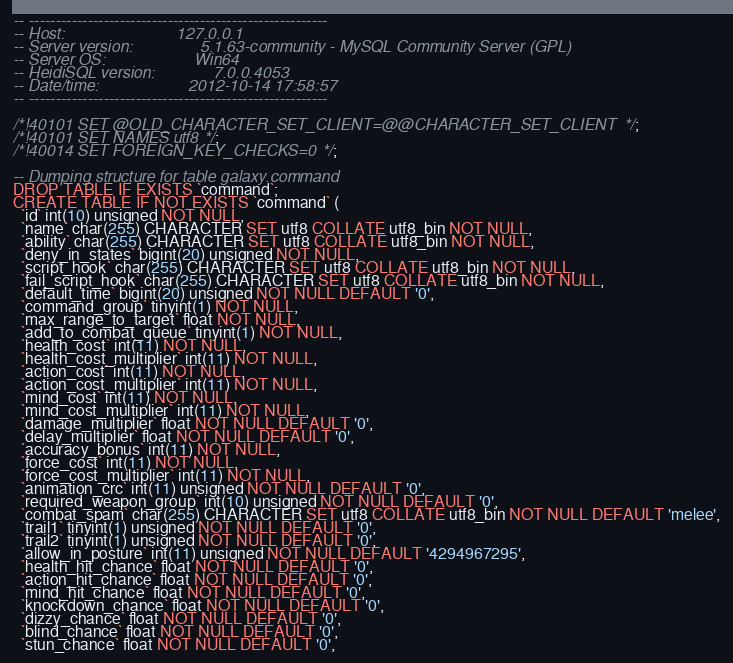<code> <loc_0><loc_0><loc_500><loc_500><_SQL_>-- --------------------------------------------------------
-- Host:                         127.0.0.1
-- Server version:               5.1.63-community - MySQL Community Server (GPL)
-- Server OS:                    Win64
-- HeidiSQL version:             7.0.0.4053
-- Date/time:                    2012-10-14 17:58:57
-- --------------------------------------------------------

/*!40101 SET @OLD_CHARACTER_SET_CLIENT=@@CHARACTER_SET_CLIENT */;
/*!40101 SET NAMES utf8 */;
/*!40014 SET FOREIGN_KEY_CHECKS=0 */;

-- Dumping structure for table galaxy.command
DROP TABLE IF EXISTS `command`;
CREATE TABLE IF NOT EXISTS `command` (
  `id` int(10) unsigned NOT NULL,
  `name` char(255) CHARACTER SET utf8 COLLATE utf8_bin NOT NULL,
  `ability` char(255) CHARACTER SET utf8 COLLATE utf8_bin NOT NULL,
  `deny_in_states` bigint(20) unsigned NOT NULL,
  `script_hook` char(255) CHARACTER SET utf8 COLLATE utf8_bin NOT NULL,
  `fail_script_hook` char(255) CHARACTER SET utf8 COLLATE utf8_bin NOT NULL,
  `default_time` bigint(20) unsigned NOT NULL DEFAULT '0',
  `command_group` tinyint(1) NOT NULL,
  `max_range_to_target` float NOT NULL,
  `add_to_combat_queue` tinyint(1) NOT NULL,
  `health_cost` int(11) NOT NULL,
  `health_cost_multiplier` int(11) NOT NULL,
  `action_cost` int(11) NOT NULL,
  `action_cost_multiplier` int(11) NOT NULL,
  `mind_cost` int(11) NOT NULL,
  `mind_cost_multiplier` int(11) NOT NULL,
  `damage_multiplier` float NOT NULL DEFAULT '0',
  `delay_multiplier` float NOT NULL DEFAULT '0',
  `accuracy_bonus` int(11) NOT NULL,
  `force_cost` int(11) NOT NULL,
  `force_cost_multiplier` int(11) NOT NULL,
  `animation_crc` int(11) unsigned NOT NULL DEFAULT '0',
  `required_weapon_group` int(10) unsigned NOT NULL DEFAULT '0',
  `combat_spam` char(255) CHARACTER SET utf8 COLLATE utf8_bin NOT NULL DEFAULT 'melee',
  `trail1` tinyint(1) unsigned NOT NULL DEFAULT '0',
  `trail2` tinyint(1) unsigned NOT NULL DEFAULT '0',
  `allow_in_posture` int(11) unsigned NOT NULL DEFAULT '4294967295',
  `health_hit_chance` float NOT NULL DEFAULT '0',
  `action_hit_chance` float NOT NULL DEFAULT '0',
  `mind_hit_chance` float NOT NULL DEFAULT '0',
  `knockdown_chance` float NOT NULL DEFAULT '0',
  `dizzy_chance` float NOT NULL DEFAULT '0',
  `blind_chance` float NOT NULL DEFAULT '0',
  `stun_chance` float NOT NULL DEFAULT '0',</code> 